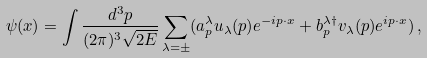Convert formula to latex. <formula><loc_0><loc_0><loc_500><loc_500>\psi ( x ) = \int \frac { d ^ { 3 } p } { ( 2 \pi ) ^ { 3 } \sqrt { 2 E } } \sum _ { \lambda = \pm } ( a _ { p } ^ { \lambda } u _ { \lambda } ( p ) e ^ { - i p \cdot x } + b _ { p } ^ { \lambda \dagger } v _ { \lambda } ( p ) e ^ { i p \cdot x } ) \, ,</formula> 